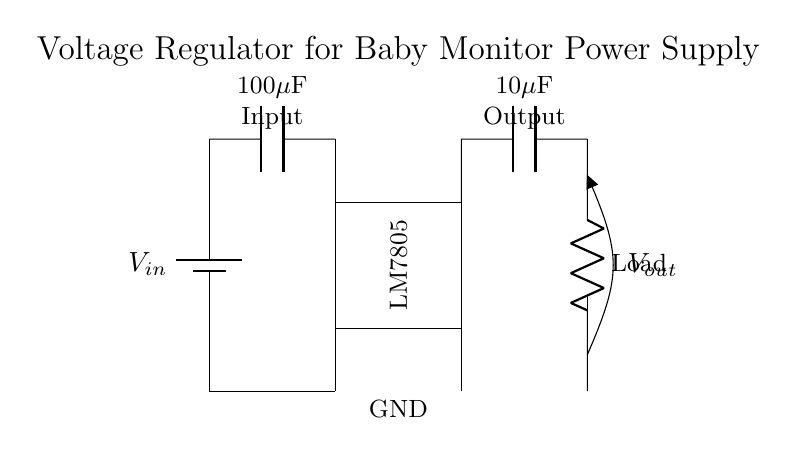What is the input voltage of this circuit? The input voltage is represented as V_in in the circuit. Since there is no specific value provided in the diagram, it essentially varies based on the battery used, but it is the source for the voltage regulator's operation.
Answer: V_in What is the output voltage of the regulator? The output voltage from the voltage regulator (LM7805) is specified as V_out. The LM7805 provides a regulated output of 5 volts.
Answer: 5 volts What is the purpose of the input capacitor in this circuit? The input capacitor, labeled as 100 microfarads, serves to stabilize the input voltage by filtering out noise and fluctuations from the power supply. This ensures a steady voltage is delivered to the regulator.
Answer: Stabilization What is the function of the load in this circuit? The load, which is represented as a resistor in the diagram, consumes the output power from the voltage regulator. It represents the device or component that requires a steady voltage supply, in this case, likely a part of the baby monitor.
Answer: Power consumption How many capacitors are present in the circuit? There are two capacitors shown in the circuit: a 100 microfarad capacitor at the input and a 10 microfarad capacitor at the output. This provides both input filtering and output stability.
Answer: Two capacitors What type of regulator is used in this circuit? The circuit employs a linear voltage regulator, specifically an LM7805, which is designed to output a fixed voltage level of 5 volts while providing regulation.
Answer: Linear voltage regulator Why is grounding important in this circuit? Grounding is crucial as it provides a common reference point for all voltage levels and completes the circuit loop, ensuring that current can flow properly. All components require a ground to function, and it helps prevent voltage spikes.
Answer: Common reference 